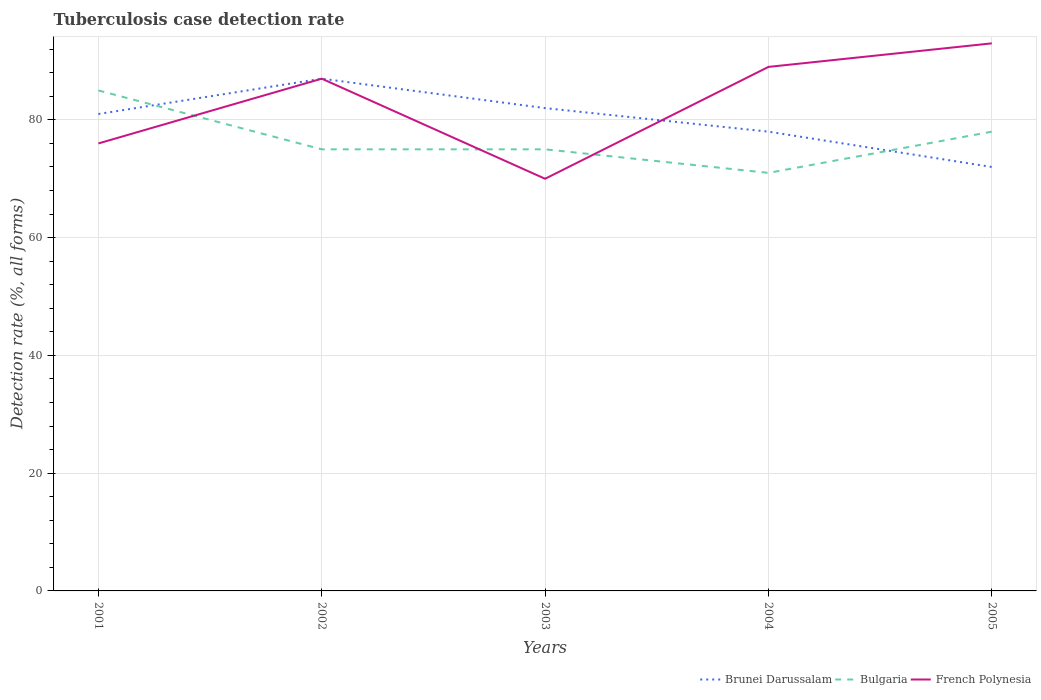How many different coloured lines are there?
Offer a terse response. 3. Across all years, what is the maximum tuberculosis case detection rate in in Bulgaria?
Make the answer very short. 71. What is the total tuberculosis case detection rate in in French Polynesia in the graph?
Offer a terse response. -19. What is the difference between the highest and the second highest tuberculosis case detection rate in in Bulgaria?
Provide a short and direct response. 14. What is the difference between the highest and the lowest tuberculosis case detection rate in in Bulgaria?
Make the answer very short. 2. What is the difference between two consecutive major ticks on the Y-axis?
Your answer should be very brief. 20. Are the values on the major ticks of Y-axis written in scientific E-notation?
Your response must be concise. No. Does the graph contain any zero values?
Your response must be concise. No. Where does the legend appear in the graph?
Your answer should be very brief. Bottom right. How are the legend labels stacked?
Make the answer very short. Horizontal. What is the title of the graph?
Make the answer very short. Tuberculosis case detection rate. What is the label or title of the X-axis?
Your answer should be very brief. Years. What is the label or title of the Y-axis?
Ensure brevity in your answer.  Detection rate (%, all forms). What is the Detection rate (%, all forms) in Brunei Darussalam in 2001?
Offer a very short reply. 81. What is the Detection rate (%, all forms) of Bulgaria in 2001?
Your response must be concise. 85. What is the Detection rate (%, all forms) of Brunei Darussalam in 2002?
Keep it short and to the point. 87. What is the Detection rate (%, all forms) of Bulgaria in 2002?
Keep it short and to the point. 75. What is the Detection rate (%, all forms) in Bulgaria in 2003?
Offer a terse response. 75. What is the Detection rate (%, all forms) of French Polynesia in 2004?
Your response must be concise. 89. What is the Detection rate (%, all forms) in Brunei Darussalam in 2005?
Make the answer very short. 72. What is the Detection rate (%, all forms) of Bulgaria in 2005?
Give a very brief answer. 78. What is the Detection rate (%, all forms) of French Polynesia in 2005?
Give a very brief answer. 93. Across all years, what is the maximum Detection rate (%, all forms) in Brunei Darussalam?
Give a very brief answer. 87. Across all years, what is the maximum Detection rate (%, all forms) in French Polynesia?
Offer a very short reply. 93. Across all years, what is the minimum Detection rate (%, all forms) in Brunei Darussalam?
Ensure brevity in your answer.  72. Across all years, what is the minimum Detection rate (%, all forms) in French Polynesia?
Keep it short and to the point. 70. What is the total Detection rate (%, all forms) in Brunei Darussalam in the graph?
Provide a succinct answer. 400. What is the total Detection rate (%, all forms) of Bulgaria in the graph?
Provide a short and direct response. 384. What is the total Detection rate (%, all forms) of French Polynesia in the graph?
Provide a succinct answer. 415. What is the difference between the Detection rate (%, all forms) in Brunei Darussalam in 2001 and that in 2002?
Your answer should be very brief. -6. What is the difference between the Detection rate (%, all forms) in Bulgaria in 2001 and that in 2002?
Provide a short and direct response. 10. What is the difference between the Detection rate (%, all forms) of Brunei Darussalam in 2001 and that in 2003?
Your response must be concise. -1. What is the difference between the Detection rate (%, all forms) in Bulgaria in 2001 and that in 2003?
Your answer should be very brief. 10. What is the difference between the Detection rate (%, all forms) of French Polynesia in 2001 and that in 2003?
Your answer should be very brief. 6. What is the difference between the Detection rate (%, all forms) of Bulgaria in 2001 and that in 2004?
Offer a very short reply. 14. What is the difference between the Detection rate (%, all forms) of French Polynesia in 2001 and that in 2004?
Your answer should be very brief. -13. What is the difference between the Detection rate (%, all forms) in Brunei Darussalam in 2001 and that in 2005?
Your response must be concise. 9. What is the difference between the Detection rate (%, all forms) of Bulgaria in 2001 and that in 2005?
Provide a succinct answer. 7. What is the difference between the Detection rate (%, all forms) in French Polynesia in 2002 and that in 2004?
Keep it short and to the point. -2. What is the difference between the Detection rate (%, all forms) in Bulgaria in 2002 and that in 2005?
Your answer should be compact. -3. What is the difference between the Detection rate (%, all forms) of French Polynesia in 2002 and that in 2005?
Ensure brevity in your answer.  -6. What is the difference between the Detection rate (%, all forms) of Brunei Darussalam in 2003 and that in 2005?
Your answer should be very brief. 10. What is the difference between the Detection rate (%, all forms) in French Polynesia in 2003 and that in 2005?
Provide a succinct answer. -23. What is the difference between the Detection rate (%, all forms) of Bulgaria in 2004 and that in 2005?
Offer a terse response. -7. What is the difference between the Detection rate (%, all forms) of Brunei Darussalam in 2001 and the Detection rate (%, all forms) of French Polynesia in 2002?
Your answer should be very brief. -6. What is the difference between the Detection rate (%, all forms) in Bulgaria in 2001 and the Detection rate (%, all forms) in French Polynesia in 2002?
Your response must be concise. -2. What is the difference between the Detection rate (%, all forms) in Bulgaria in 2001 and the Detection rate (%, all forms) in French Polynesia in 2003?
Your answer should be very brief. 15. What is the difference between the Detection rate (%, all forms) in Brunei Darussalam in 2001 and the Detection rate (%, all forms) in Bulgaria in 2004?
Give a very brief answer. 10. What is the difference between the Detection rate (%, all forms) in Brunei Darussalam in 2001 and the Detection rate (%, all forms) in French Polynesia in 2004?
Your response must be concise. -8. What is the difference between the Detection rate (%, all forms) in Brunei Darussalam in 2001 and the Detection rate (%, all forms) in French Polynesia in 2005?
Offer a very short reply. -12. What is the difference between the Detection rate (%, all forms) in Bulgaria in 2001 and the Detection rate (%, all forms) in French Polynesia in 2005?
Your response must be concise. -8. What is the difference between the Detection rate (%, all forms) of Brunei Darussalam in 2002 and the Detection rate (%, all forms) of Bulgaria in 2003?
Provide a succinct answer. 12. What is the difference between the Detection rate (%, all forms) in Brunei Darussalam in 2002 and the Detection rate (%, all forms) in French Polynesia in 2003?
Your response must be concise. 17. What is the difference between the Detection rate (%, all forms) in Brunei Darussalam in 2002 and the Detection rate (%, all forms) in French Polynesia in 2005?
Offer a terse response. -6. What is the difference between the Detection rate (%, all forms) in Brunei Darussalam in 2003 and the Detection rate (%, all forms) in Bulgaria in 2004?
Provide a succinct answer. 11. What is the difference between the Detection rate (%, all forms) in Brunei Darussalam in 2003 and the Detection rate (%, all forms) in French Polynesia in 2005?
Your answer should be very brief. -11. What is the difference between the Detection rate (%, all forms) in Brunei Darussalam in 2004 and the Detection rate (%, all forms) in French Polynesia in 2005?
Give a very brief answer. -15. What is the average Detection rate (%, all forms) of Brunei Darussalam per year?
Give a very brief answer. 80. What is the average Detection rate (%, all forms) of Bulgaria per year?
Your answer should be very brief. 76.8. In the year 2001, what is the difference between the Detection rate (%, all forms) in Brunei Darussalam and Detection rate (%, all forms) in Bulgaria?
Make the answer very short. -4. In the year 2001, what is the difference between the Detection rate (%, all forms) in Brunei Darussalam and Detection rate (%, all forms) in French Polynesia?
Your response must be concise. 5. In the year 2002, what is the difference between the Detection rate (%, all forms) of Brunei Darussalam and Detection rate (%, all forms) of French Polynesia?
Provide a succinct answer. 0. In the year 2002, what is the difference between the Detection rate (%, all forms) in Bulgaria and Detection rate (%, all forms) in French Polynesia?
Offer a terse response. -12. In the year 2003, what is the difference between the Detection rate (%, all forms) in Brunei Darussalam and Detection rate (%, all forms) in Bulgaria?
Your answer should be compact. 7. In the year 2003, what is the difference between the Detection rate (%, all forms) of Brunei Darussalam and Detection rate (%, all forms) of French Polynesia?
Your answer should be compact. 12. In the year 2003, what is the difference between the Detection rate (%, all forms) in Bulgaria and Detection rate (%, all forms) in French Polynesia?
Ensure brevity in your answer.  5. In the year 2004, what is the difference between the Detection rate (%, all forms) of Brunei Darussalam and Detection rate (%, all forms) of French Polynesia?
Ensure brevity in your answer.  -11. In the year 2004, what is the difference between the Detection rate (%, all forms) in Bulgaria and Detection rate (%, all forms) in French Polynesia?
Provide a succinct answer. -18. In the year 2005, what is the difference between the Detection rate (%, all forms) of Brunei Darussalam and Detection rate (%, all forms) of French Polynesia?
Give a very brief answer. -21. In the year 2005, what is the difference between the Detection rate (%, all forms) in Bulgaria and Detection rate (%, all forms) in French Polynesia?
Make the answer very short. -15. What is the ratio of the Detection rate (%, all forms) of Bulgaria in 2001 to that in 2002?
Provide a succinct answer. 1.13. What is the ratio of the Detection rate (%, all forms) of French Polynesia in 2001 to that in 2002?
Your answer should be compact. 0.87. What is the ratio of the Detection rate (%, all forms) in Brunei Darussalam in 2001 to that in 2003?
Provide a short and direct response. 0.99. What is the ratio of the Detection rate (%, all forms) in Bulgaria in 2001 to that in 2003?
Your answer should be compact. 1.13. What is the ratio of the Detection rate (%, all forms) of French Polynesia in 2001 to that in 2003?
Your answer should be very brief. 1.09. What is the ratio of the Detection rate (%, all forms) of Brunei Darussalam in 2001 to that in 2004?
Your answer should be very brief. 1.04. What is the ratio of the Detection rate (%, all forms) in Bulgaria in 2001 to that in 2004?
Your answer should be compact. 1.2. What is the ratio of the Detection rate (%, all forms) of French Polynesia in 2001 to that in 2004?
Provide a succinct answer. 0.85. What is the ratio of the Detection rate (%, all forms) of Bulgaria in 2001 to that in 2005?
Your answer should be very brief. 1.09. What is the ratio of the Detection rate (%, all forms) of French Polynesia in 2001 to that in 2005?
Offer a terse response. 0.82. What is the ratio of the Detection rate (%, all forms) in Brunei Darussalam in 2002 to that in 2003?
Give a very brief answer. 1.06. What is the ratio of the Detection rate (%, all forms) of French Polynesia in 2002 to that in 2003?
Keep it short and to the point. 1.24. What is the ratio of the Detection rate (%, all forms) in Brunei Darussalam in 2002 to that in 2004?
Provide a short and direct response. 1.12. What is the ratio of the Detection rate (%, all forms) of Bulgaria in 2002 to that in 2004?
Keep it short and to the point. 1.06. What is the ratio of the Detection rate (%, all forms) in French Polynesia in 2002 to that in 2004?
Make the answer very short. 0.98. What is the ratio of the Detection rate (%, all forms) in Brunei Darussalam in 2002 to that in 2005?
Offer a terse response. 1.21. What is the ratio of the Detection rate (%, all forms) of Bulgaria in 2002 to that in 2005?
Ensure brevity in your answer.  0.96. What is the ratio of the Detection rate (%, all forms) in French Polynesia in 2002 to that in 2005?
Ensure brevity in your answer.  0.94. What is the ratio of the Detection rate (%, all forms) of Brunei Darussalam in 2003 to that in 2004?
Your answer should be very brief. 1.05. What is the ratio of the Detection rate (%, all forms) of Bulgaria in 2003 to that in 2004?
Offer a terse response. 1.06. What is the ratio of the Detection rate (%, all forms) in French Polynesia in 2003 to that in 2004?
Give a very brief answer. 0.79. What is the ratio of the Detection rate (%, all forms) of Brunei Darussalam in 2003 to that in 2005?
Ensure brevity in your answer.  1.14. What is the ratio of the Detection rate (%, all forms) of Bulgaria in 2003 to that in 2005?
Offer a very short reply. 0.96. What is the ratio of the Detection rate (%, all forms) of French Polynesia in 2003 to that in 2005?
Provide a short and direct response. 0.75. What is the ratio of the Detection rate (%, all forms) of Brunei Darussalam in 2004 to that in 2005?
Offer a terse response. 1.08. What is the ratio of the Detection rate (%, all forms) in Bulgaria in 2004 to that in 2005?
Your response must be concise. 0.91. What is the ratio of the Detection rate (%, all forms) of French Polynesia in 2004 to that in 2005?
Your response must be concise. 0.96. What is the difference between the highest and the lowest Detection rate (%, all forms) of Brunei Darussalam?
Provide a succinct answer. 15. What is the difference between the highest and the lowest Detection rate (%, all forms) in Bulgaria?
Your answer should be compact. 14. What is the difference between the highest and the lowest Detection rate (%, all forms) of French Polynesia?
Keep it short and to the point. 23. 